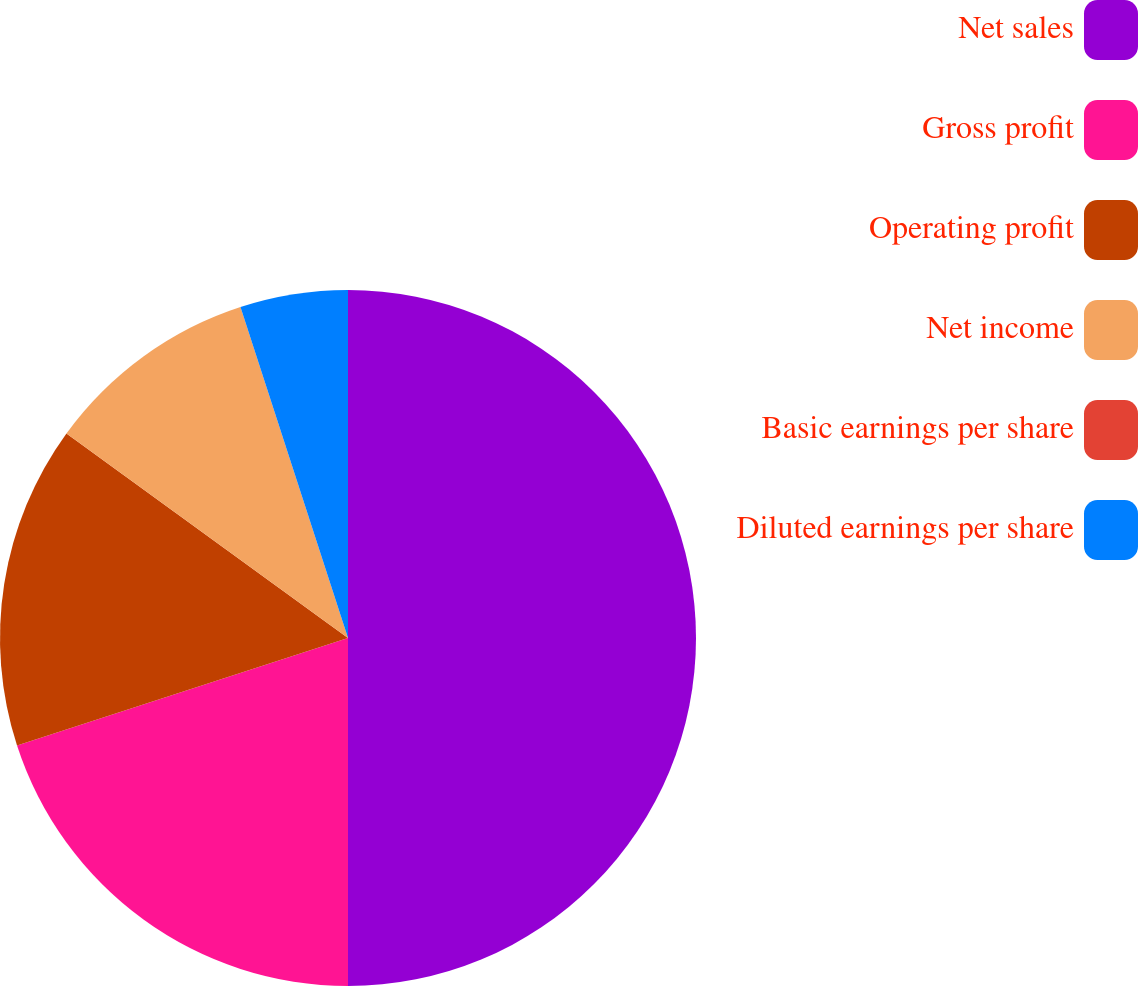Convert chart to OTSL. <chart><loc_0><loc_0><loc_500><loc_500><pie_chart><fcel>Net sales<fcel>Gross profit<fcel>Operating profit<fcel>Net income<fcel>Basic earnings per share<fcel>Diluted earnings per share<nl><fcel>50.0%<fcel>20.0%<fcel>15.0%<fcel>10.0%<fcel>0.0%<fcel>5.0%<nl></chart> 